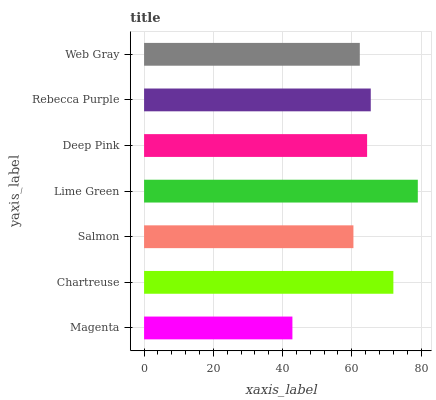Is Magenta the minimum?
Answer yes or no. Yes. Is Lime Green the maximum?
Answer yes or no. Yes. Is Chartreuse the minimum?
Answer yes or no. No. Is Chartreuse the maximum?
Answer yes or no. No. Is Chartreuse greater than Magenta?
Answer yes or no. Yes. Is Magenta less than Chartreuse?
Answer yes or no. Yes. Is Magenta greater than Chartreuse?
Answer yes or no. No. Is Chartreuse less than Magenta?
Answer yes or no. No. Is Deep Pink the high median?
Answer yes or no. Yes. Is Deep Pink the low median?
Answer yes or no. Yes. Is Salmon the high median?
Answer yes or no. No. Is Magenta the low median?
Answer yes or no. No. 